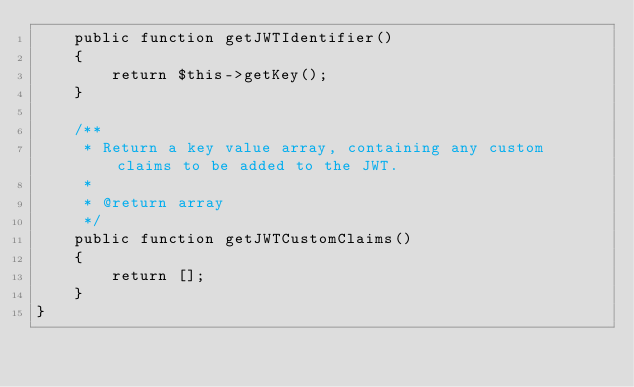<code> <loc_0><loc_0><loc_500><loc_500><_PHP_>    public function getJWTIdentifier()
    {
        return $this->getKey();
    }

    /**
     * Return a key value array, containing any custom claims to be added to the JWT.
     *
     * @return array
     */
    public function getJWTCustomClaims()
    {
        return [];
    }
}


</code> 